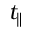<formula> <loc_0><loc_0><loc_500><loc_500>t _ { \| }</formula> 